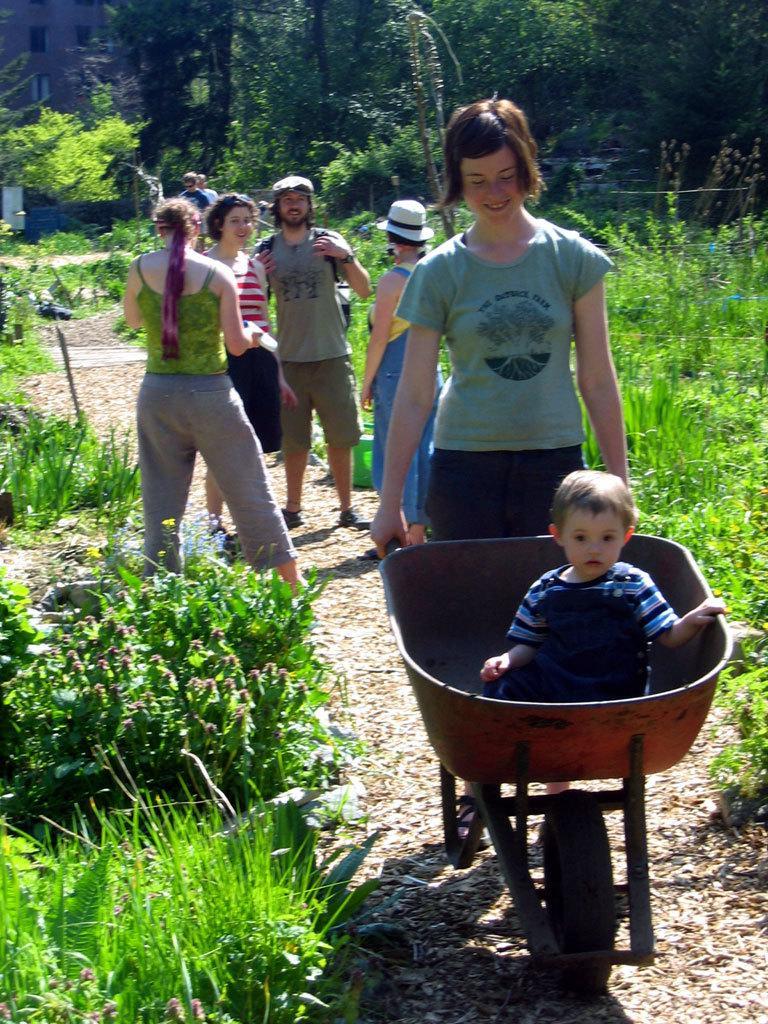In one or two sentences, can you explain what this image depicts? In this picture I can observe some people in this path. There is a kid sitting in the trolley. There are some plants and grass on the ground. In the background there are trees. 